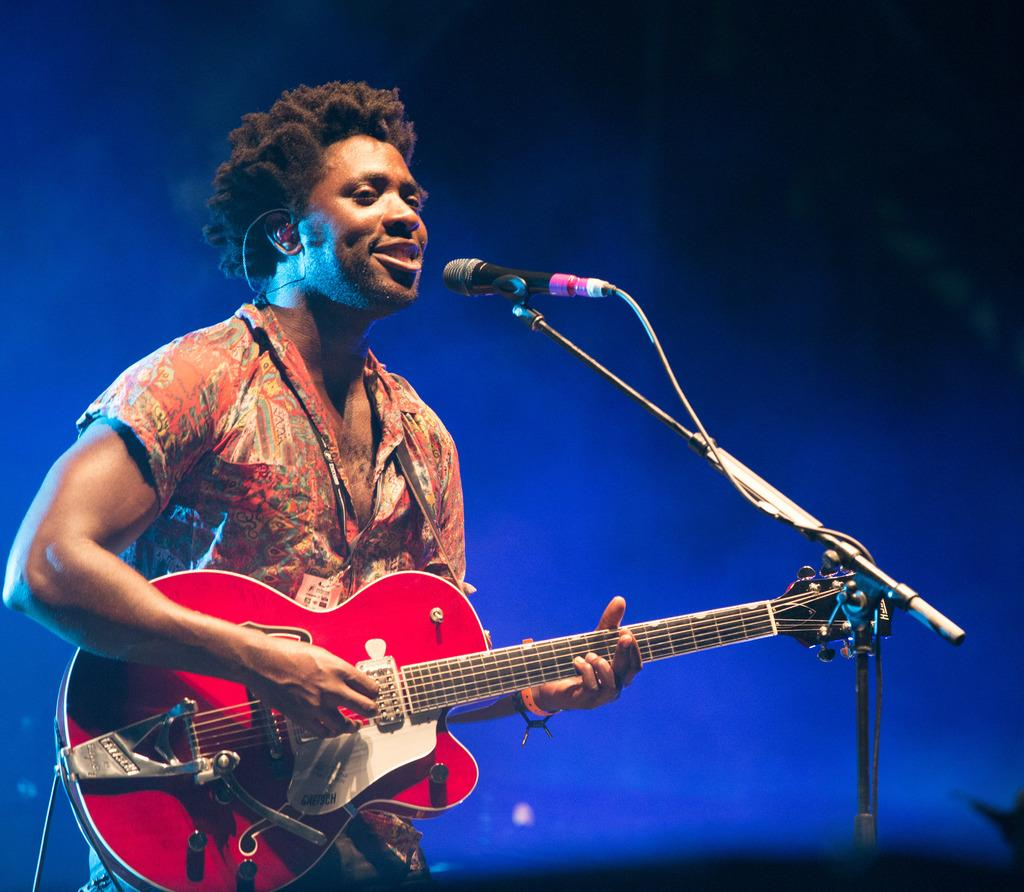What is the main subject of the image? The main subject of the image is a man. What is the man doing in the image? The man is standing, singing, and playing a guitar. What is in front of the man that he might be using? There is a microphone and a microphone stand in front of the man. What type of bread is the man holding in the image? There is no bread present in the image; the man is holding a guitar. Is the man in a prison in the image? There is no indication of a prison or any prison-related elements in the image. 